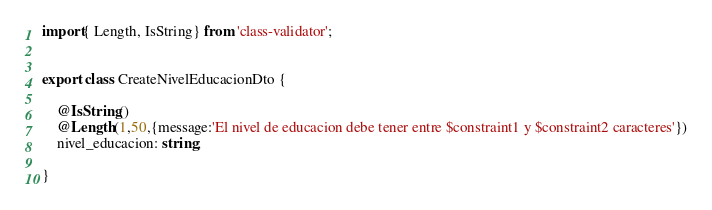<code> <loc_0><loc_0><loc_500><loc_500><_TypeScript_>import{ Length, IsString} from 'class-validator';


export class CreateNivelEducacionDto {
    
    @IsString()
    @Length(1,50,{message:'El nivel de educacion debe tener entre $constraint1 y $constraint2 caracteres'})
    nivel_educacion: string;    

}</code> 